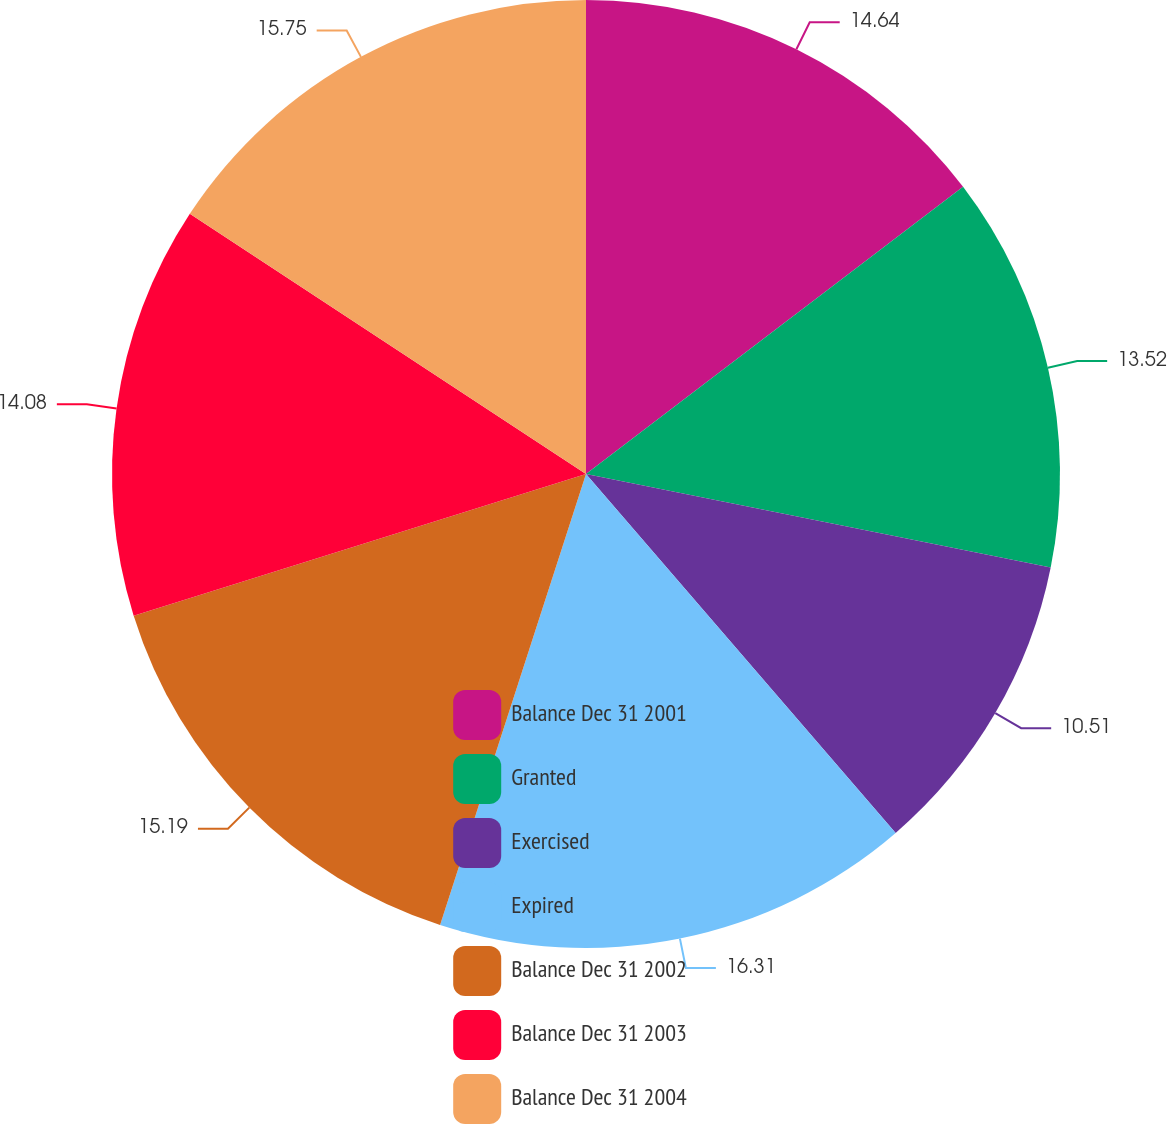<chart> <loc_0><loc_0><loc_500><loc_500><pie_chart><fcel>Balance Dec 31 2001<fcel>Granted<fcel>Exercised<fcel>Expired<fcel>Balance Dec 31 2002<fcel>Balance Dec 31 2003<fcel>Balance Dec 31 2004<nl><fcel>14.64%<fcel>13.52%<fcel>10.51%<fcel>16.31%<fcel>15.19%<fcel>14.08%<fcel>15.75%<nl></chart> 